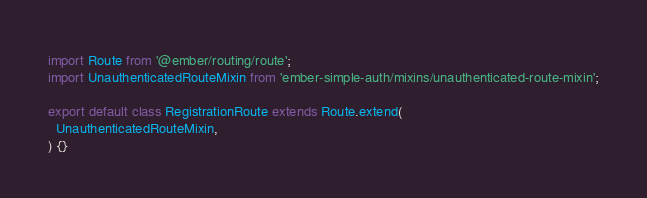<code> <loc_0><loc_0><loc_500><loc_500><_JavaScript_>import Route from '@ember/routing/route';
import UnauthenticatedRouteMixin from 'ember-simple-auth/mixins/unauthenticated-route-mixin';

export default class RegistrationRoute extends Route.extend(
  UnauthenticatedRouteMixin,
) {}
</code> 